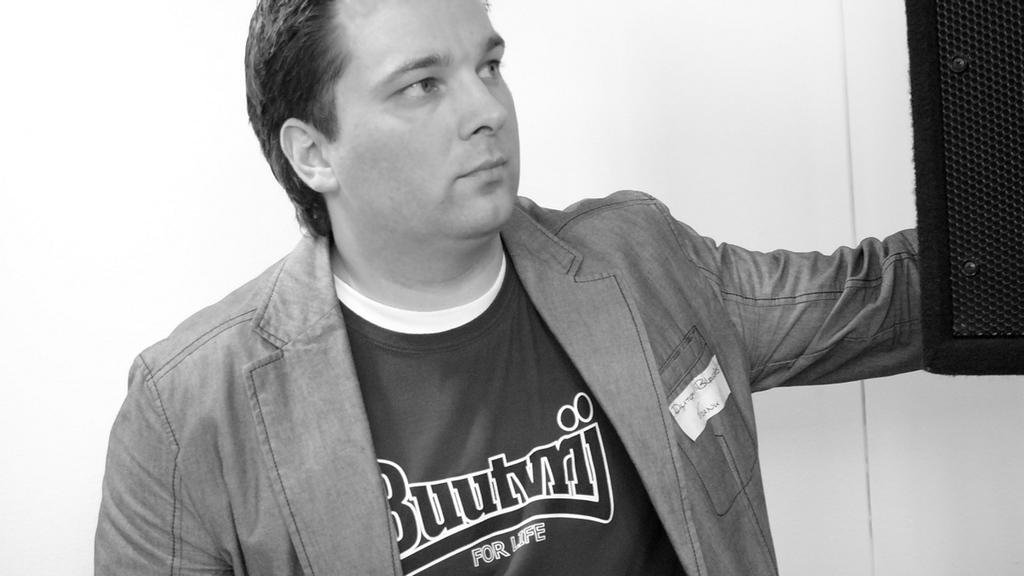<image>
Offer a succinct explanation of the picture presented. A man's shirt says Buutvrij for life on it. 